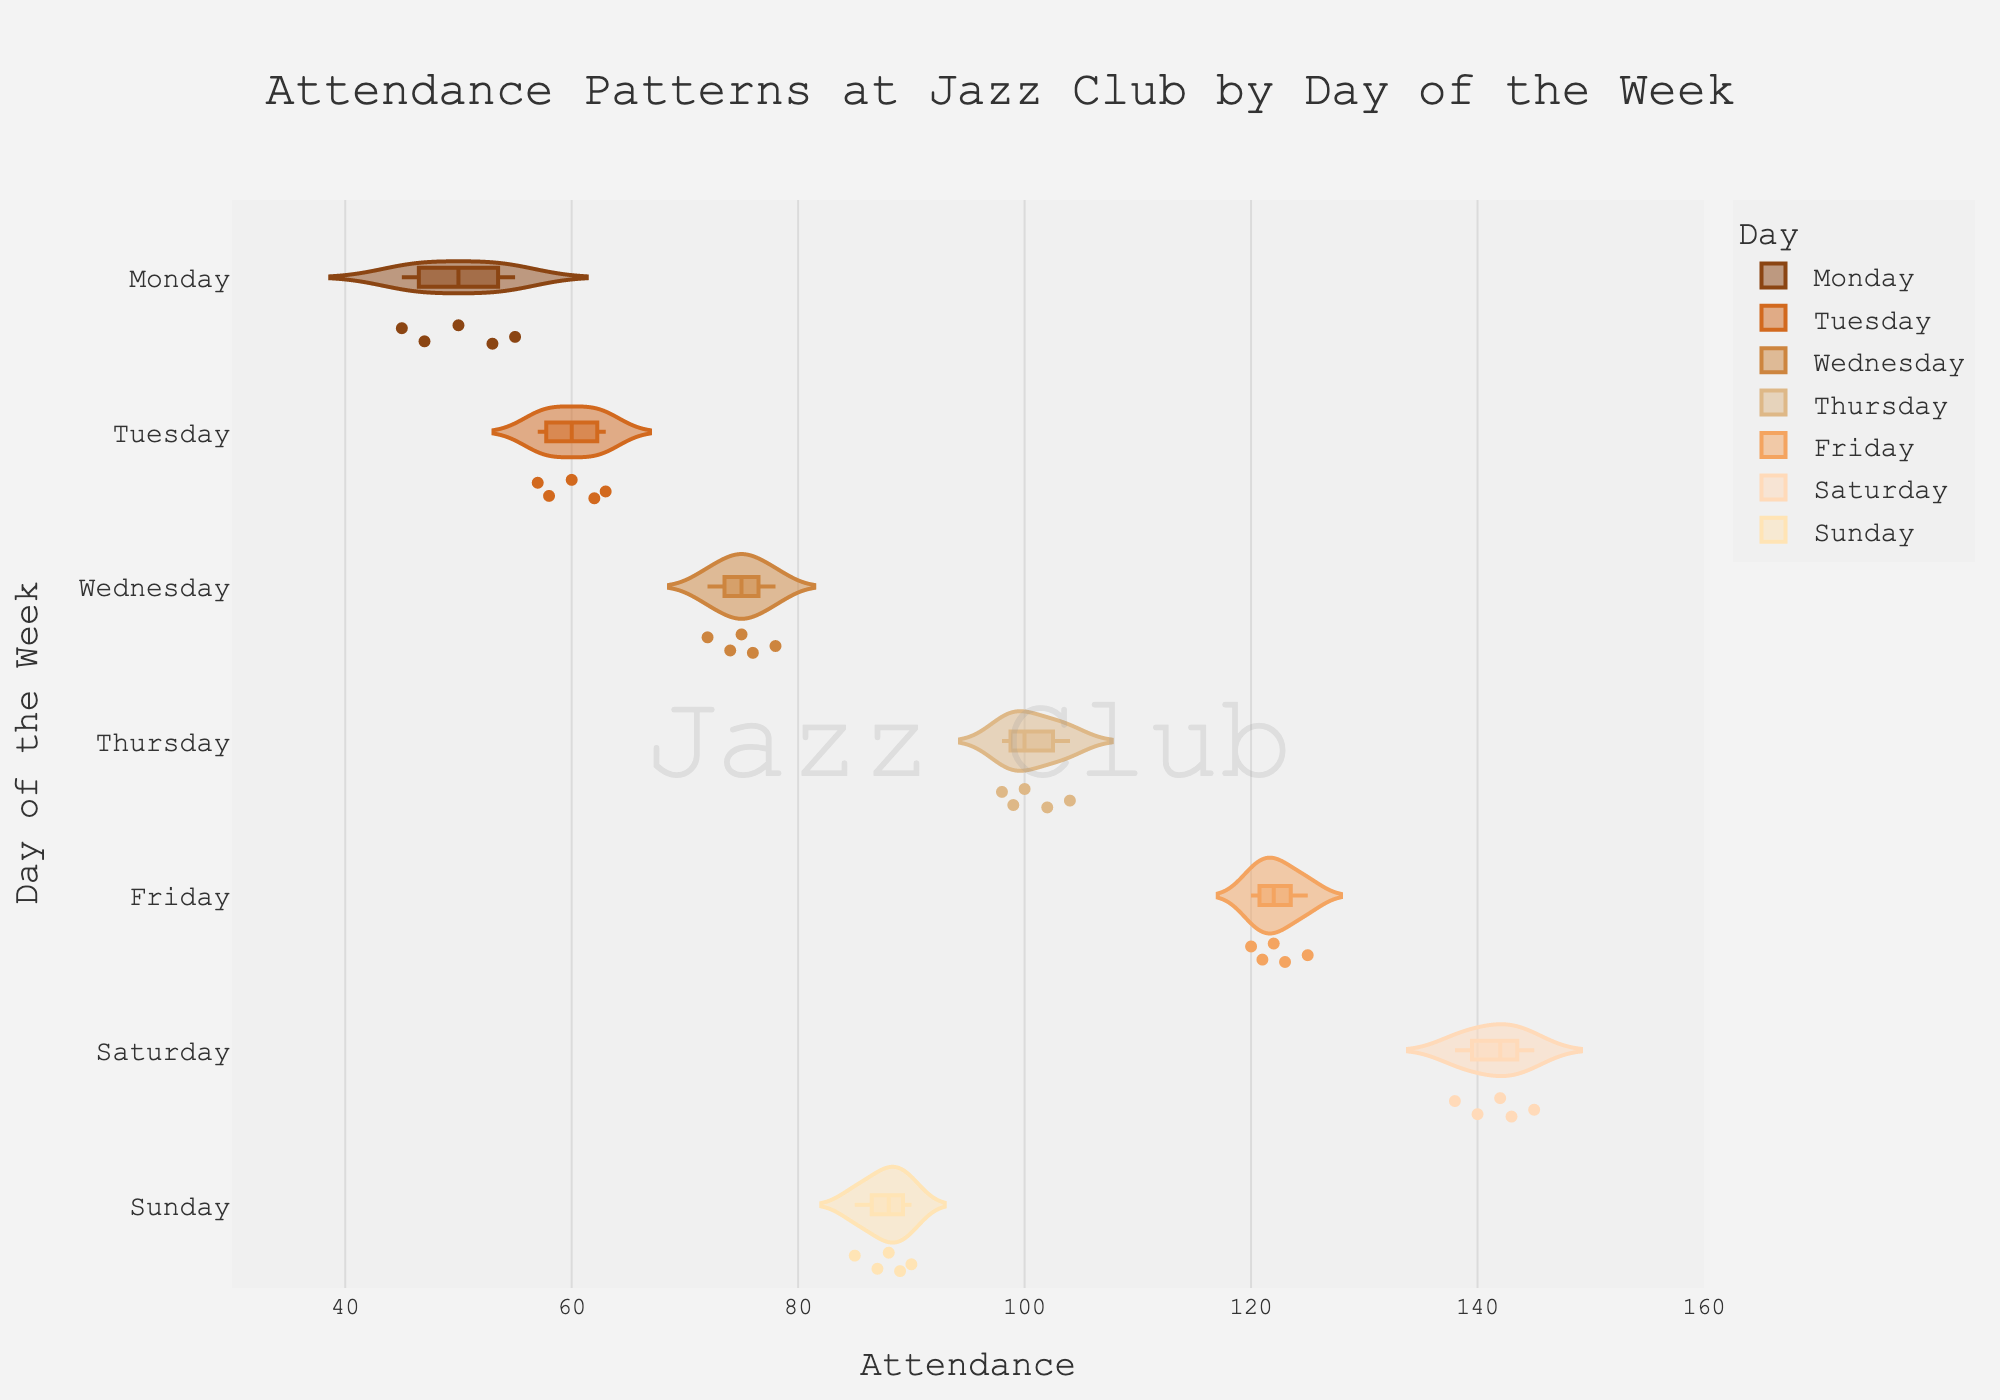What does the title of the plot specify? The title is located at the top center of the plot and describes the main subject of the visual, which is "Attendance Patterns at Jazz Club by Day of the Week".
Answer: Attendance Patterns at Jazz Club by Day of the Week What does the x-axis represent? The x-axis measures the number of people attending the jazz club, with ticks showing the attendance count.
Answer: Attendance What is the range of attendance recorded on Friday? The length of the horizontal violin plot for Friday on the x-axis indicates the minimum and maximum attendance values recorded.
Answer: 120 to 125 On which day is the attendance the most widely spread? The day with the most varied attendance will have the widest horizontal violin plot. By visual inspection, Saturday shows the broadest spread.
Answer: Saturday Which day of the week has the lowest median attendance? The median value can be identified by the line inside the box plot within each violin plot. The lowest median is observed for Monday.
Answer: Monday How does the average attendance on Tuesday compare to that on Sunday? In the box plot within the violin chart, the central tendency can be observed through the box and its line, indicating the average is slightly higher on Tuesday compared to Sunday.
Answer: Tuesday is higher What is the overall pattern observed in attendance from Monday to Sunday? Observing the general shape and distribution of data points in the violin plots, attendance increases from Monday, peaks on Saturday, and falls again on Sunday.
Answer: Increases, peaks on Saturday, then falls Which day has a maximum attendance value that is closest to 100? The upper end of the violin plots shows the maximum attendance. Thursday's maximum value is closest to 100.
Answer: Thursday What is the range of attendance for Thursdays? Reading from the Thursday violin plot, the lowest and highest numbers recorded for attendance provide the range. It ranges from 98 to 104.
Answer: 98 to 104 